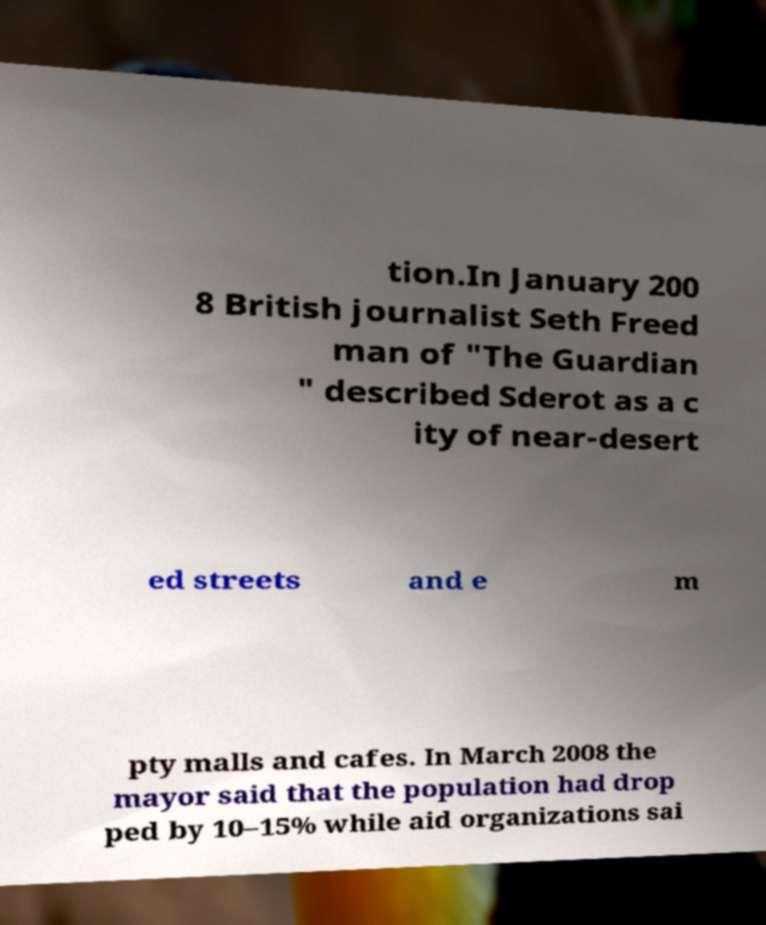Can you read and provide the text displayed in the image?This photo seems to have some interesting text. Can you extract and type it out for me? tion.In January 200 8 British journalist Seth Freed man of "The Guardian " described Sderot as a c ity of near-desert ed streets and e m pty malls and cafes. In March 2008 the mayor said that the population had drop ped by 10–15% while aid organizations sai 